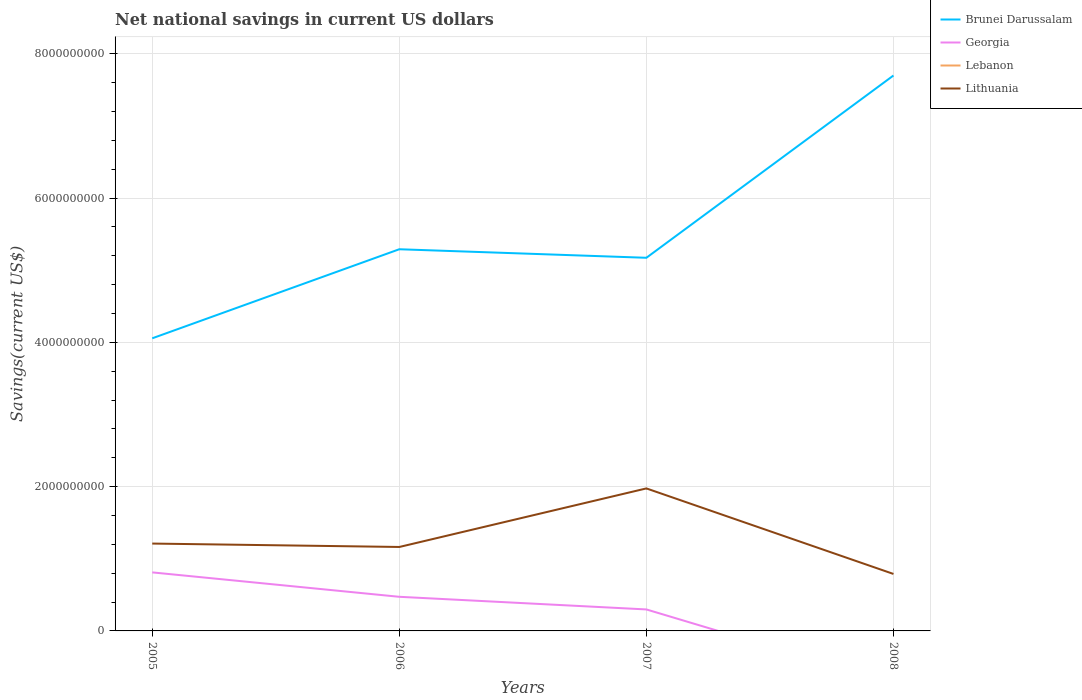How many different coloured lines are there?
Offer a very short reply. 3. Across all years, what is the maximum net national savings in Lithuania?
Give a very brief answer. 7.90e+08. What is the total net national savings in Georgia in the graph?
Your answer should be very brief. 1.75e+08. What is the difference between the highest and the second highest net national savings in Lithuania?
Your answer should be very brief. 1.19e+09. Is the net national savings in Brunei Darussalam strictly greater than the net national savings in Georgia over the years?
Your answer should be compact. No. How many lines are there?
Give a very brief answer. 3. Does the graph contain any zero values?
Keep it short and to the point. Yes. Does the graph contain grids?
Give a very brief answer. Yes. Where does the legend appear in the graph?
Provide a succinct answer. Top right. How are the legend labels stacked?
Ensure brevity in your answer.  Vertical. What is the title of the graph?
Make the answer very short. Net national savings in current US dollars. Does "Serbia" appear as one of the legend labels in the graph?
Give a very brief answer. No. What is the label or title of the Y-axis?
Make the answer very short. Savings(current US$). What is the Savings(current US$) of Brunei Darussalam in 2005?
Keep it short and to the point. 4.06e+09. What is the Savings(current US$) of Georgia in 2005?
Provide a short and direct response. 8.11e+08. What is the Savings(current US$) in Lebanon in 2005?
Your response must be concise. 0. What is the Savings(current US$) of Lithuania in 2005?
Ensure brevity in your answer.  1.21e+09. What is the Savings(current US$) of Brunei Darussalam in 2006?
Your answer should be very brief. 5.29e+09. What is the Savings(current US$) in Georgia in 2006?
Give a very brief answer. 4.73e+08. What is the Savings(current US$) of Lithuania in 2006?
Offer a terse response. 1.16e+09. What is the Savings(current US$) in Brunei Darussalam in 2007?
Offer a very short reply. 5.17e+09. What is the Savings(current US$) in Georgia in 2007?
Offer a very short reply. 2.98e+08. What is the Savings(current US$) in Lebanon in 2007?
Provide a short and direct response. 0. What is the Savings(current US$) of Lithuania in 2007?
Offer a very short reply. 1.98e+09. What is the Savings(current US$) of Brunei Darussalam in 2008?
Offer a terse response. 7.70e+09. What is the Savings(current US$) of Lebanon in 2008?
Keep it short and to the point. 0. What is the Savings(current US$) of Lithuania in 2008?
Give a very brief answer. 7.90e+08. Across all years, what is the maximum Savings(current US$) of Brunei Darussalam?
Offer a terse response. 7.70e+09. Across all years, what is the maximum Savings(current US$) of Georgia?
Give a very brief answer. 8.11e+08. Across all years, what is the maximum Savings(current US$) of Lithuania?
Your answer should be very brief. 1.98e+09. Across all years, what is the minimum Savings(current US$) of Brunei Darussalam?
Your answer should be compact. 4.06e+09. Across all years, what is the minimum Savings(current US$) of Georgia?
Your response must be concise. 0. Across all years, what is the minimum Savings(current US$) in Lithuania?
Your response must be concise. 7.90e+08. What is the total Savings(current US$) in Brunei Darussalam in the graph?
Make the answer very short. 2.22e+1. What is the total Savings(current US$) of Georgia in the graph?
Make the answer very short. 1.58e+09. What is the total Savings(current US$) of Lithuania in the graph?
Offer a terse response. 5.14e+09. What is the difference between the Savings(current US$) in Brunei Darussalam in 2005 and that in 2006?
Ensure brevity in your answer.  -1.23e+09. What is the difference between the Savings(current US$) of Georgia in 2005 and that in 2006?
Give a very brief answer. 3.38e+08. What is the difference between the Savings(current US$) in Lithuania in 2005 and that in 2006?
Provide a short and direct response. 4.73e+07. What is the difference between the Savings(current US$) of Brunei Darussalam in 2005 and that in 2007?
Your answer should be compact. -1.12e+09. What is the difference between the Savings(current US$) of Georgia in 2005 and that in 2007?
Offer a very short reply. 5.14e+08. What is the difference between the Savings(current US$) of Lithuania in 2005 and that in 2007?
Offer a very short reply. -7.64e+08. What is the difference between the Savings(current US$) in Brunei Darussalam in 2005 and that in 2008?
Offer a very short reply. -3.64e+09. What is the difference between the Savings(current US$) in Lithuania in 2005 and that in 2008?
Make the answer very short. 4.21e+08. What is the difference between the Savings(current US$) in Brunei Darussalam in 2006 and that in 2007?
Make the answer very short. 1.18e+08. What is the difference between the Savings(current US$) in Georgia in 2006 and that in 2007?
Your answer should be very brief. 1.75e+08. What is the difference between the Savings(current US$) in Lithuania in 2006 and that in 2007?
Your response must be concise. -8.12e+08. What is the difference between the Savings(current US$) in Brunei Darussalam in 2006 and that in 2008?
Offer a very short reply. -2.41e+09. What is the difference between the Savings(current US$) in Lithuania in 2006 and that in 2008?
Offer a terse response. 3.74e+08. What is the difference between the Savings(current US$) of Brunei Darussalam in 2007 and that in 2008?
Ensure brevity in your answer.  -2.53e+09. What is the difference between the Savings(current US$) of Lithuania in 2007 and that in 2008?
Offer a very short reply. 1.19e+09. What is the difference between the Savings(current US$) in Brunei Darussalam in 2005 and the Savings(current US$) in Georgia in 2006?
Keep it short and to the point. 3.58e+09. What is the difference between the Savings(current US$) in Brunei Darussalam in 2005 and the Savings(current US$) in Lithuania in 2006?
Offer a very short reply. 2.89e+09. What is the difference between the Savings(current US$) in Georgia in 2005 and the Savings(current US$) in Lithuania in 2006?
Your response must be concise. -3.52e+08. What is the difference between the Savings(current US$) in Brunei Darussalam in 2005 and the Savings(current US$) in Georgia in 2007?
Provide a succinct answer. 3.76e+09. What is the difference between the Savings(current US$) in Brunei Darussalam in 2005 and the Savings(current US$) in Lithuania in 2007?
Give a very brief answer. 2.08e+09. What is the difference between the Savings(current US$) of Georgia in 2005 and the Savings(current US$) of Lithuania in 2007?
Offer a terse response. -1.16e+09. What is the difference between the Savings(current US$) of Brunei Darussalam in 2005 and the Savings(current US$) of Lithuania in 2008?
Your response must be concise. 3.27e+09. What is the difference between the Savings(current US$) of Georgia in 2005 and the Savings(current US$) of Lithuania in 2008?
Your answer should be very brief. 2.15e+07. What is the difference between the Savings(current US$) in Brunei Darussalam in 2006 and the Savings(current US$) in Georgia in 2007?
Your answer should be very brief. 4.99e+09. What is the difference between the Savings(current US$) of Brunei Darussalam in 2006 and the Savings(current US$) of Lithuania in 2007?
Give a very brief answer. 3.32e+09. What is the difference between the Savings(current US$) of Georgia in 2006 and the Savings(current US$) of Lithuania in 2007?
Ensure brevity in your answer.  -1.50e+09. What is the difference between the Savings(current US$) of Brunei Darussalam in 2006 and the Savings(current US$) of Lithuania in 2008?
Give a very brief answer. 4.50e+09. What is the difference between the Savings(current US$) of Georgia in 2006 and the Savings(current US$) of Lithuania in 2008?
Keep it short and to the point. -3.17e+08. What is the difference between the Savings(current US$) of Brunei Darussalam in 2007 and the Savings(current US$) of Lithuania in 2008?
Your answer should be compact. 4.38e+09. What is the difference between the Savings(current US$) of Georgia in 2007 and the Savings(current US$) of Lithuania in 2008?
Make the answer very short. -4.92e+08. What is the average Savings(current US$) in Brunei Darussalam per year?
Make the answer very short. 5.55e+09. What is the average Savings(current US$) of Georgia per year?
Ensure brevity in your answer.  3.96e+08. What is the average Savings(current US$) in Lithuania per year?
Provide a short and direct response. 1.28e+09. In the year 2005, what is the difference between the Savings(current US$) of Brunei Darussalam and Savings(current US$) of Georgia?
Your response must be concise. 3.24e+09. In the year 2005, what is the difference between the Savings(current US$) in Brunei Darussalam and Savings(current US$) in Lithuania?
Your answer should be compact. 2.85e+09. In the year 2005, what is the difference between the Savings(current US$) of Georgia and Savings(current US$) of Lithuania?
Make the answer very short. -3.99e+08. In the year 2006, what is the difference between the Savings(current US$) of Brunei Darussalam and Savings(current US$) of Georgia?
Give a very brief answer. 4.82e+09. In the year 2006, what is the difference between the Savings(current US$) of Brunei Darussalam and Savings(current US$) of Lithuania?
Offer a terse response. 4.13e+09. In the year 2006, what is the difference between the Savings(current US$) in Georgia and Savings(current US$) in Lithuania?
Provide a succinct answer. -6.91e+08. In the year 2007, what is the difference between the Savings(current US$) in Brunei Darussalam and Savings(current US$) in Georgia?
Make the answer very short. 4.87e+09. In the year 2007, what is the difference between the Savings(current US$) in Brunei Darussalam and Savings(current US$) in Lithuania?
Offer a very short reply. 3.20e+09. In the year 2007, what is the difference between the Savings(current US$) of Georgia and Savings(current US$) of Lithuania?
Ensure brevity in your answer.  -1.68e+09. In the year 2008, what is the difference between the Savings(current US$) in Brunei Darussalam and Savings(current US$) in Lithuania?
Your answer should be very brief. 6.91e+09. What is the ratio of the Savings(current US$) of Brunei Darussalam in 2005 to that in 2006?
Offer a very short reply. 0.77. What is the ratio of the Savings(current US$) of Georgia in 2005 to that in 2006?
Make the answer very short. 1.72. What is the ratio of the Savings(current US$) of Lithuania in 2005 to that in 2006?
Ensure brevity in your answer.  1.04. What is the ratio of the Savings(current US$) of Brunei Darussalam in 2005 to that in 2007?
Your answer should be compact. 0.78. What is the ratio of the Savings(current US$) of Georgia in 2005 to that in 2007?
Provide a succinct answer. 2.73. What is the ratio of the Savings(current US$) in Lithuania in 2005 to that in 2007?
Your response must be concise. 0.61. What is the ratio of the Savings(current US$) of Brunei Darussalam in 2005 to that in 2008?
Offer a very short reply. 0.53. What is the ratio of the Savings(current US$) of Lithuania in 2005 to that in 2008?
Your answer should be compact. 1.53. What is the ratio of the Savings(current US$) of Brunei Darussalam in 2006 to that in 2007?
Make the answer very short. 1.02. What is the ratio of the Savings(current US$) in Georgia in 2006 to that in 2007?
Provide a succinct answer. 1.59. What is the ratio of the Savings(current US$) of Lithuania in 2006 to that in 2007?
Ensure brevity in your answer.  0.59. What is the ratio of the Savings(current US$) in Brunei Darussalam in 2006 to that in 2008?
Offer a very short reply. 0.69. What is the ratio of the Savings(current US$) in Lithuania in 2006 to that in 2008?
Keep it short and to the point. 1.47. What is the ratio of the Savings(current US$) of Brunei Darussalam in 2007 to that in 2008?
Offer a very short reply. 0.67. What is the ratio of the Savings(current US$) of Lithuania in 2007 to that in 2008?
Offer a terse response. 2.5. What is the difference between the highest and the second highest Savings(current US$) in Brunei Darussalam?
Make the answer very short. 2.41e+09. What is the difference between the highest and the second highest Savings(current US$) in Georgia?
Ensure brevity in your answer.  3.38e+08. What is the difference between the highest and the second highest Savings(current US$) in Lithuania?
Your response must be concise. 7.64e+08. What is the difference between the highest and the lowest Savings(current US$) in Brunei Darussalam?
Offer a very short reply. 3.64e+09. What is the difference between the highest and the lowest Savings(current US$) of Georgia?
Ensure brevity in your answer.  8.11e+08. What is the difference between the highest and the lowest Savings(current US$) of Lithuania?
Your answer should be compact. 1.19e+09. 